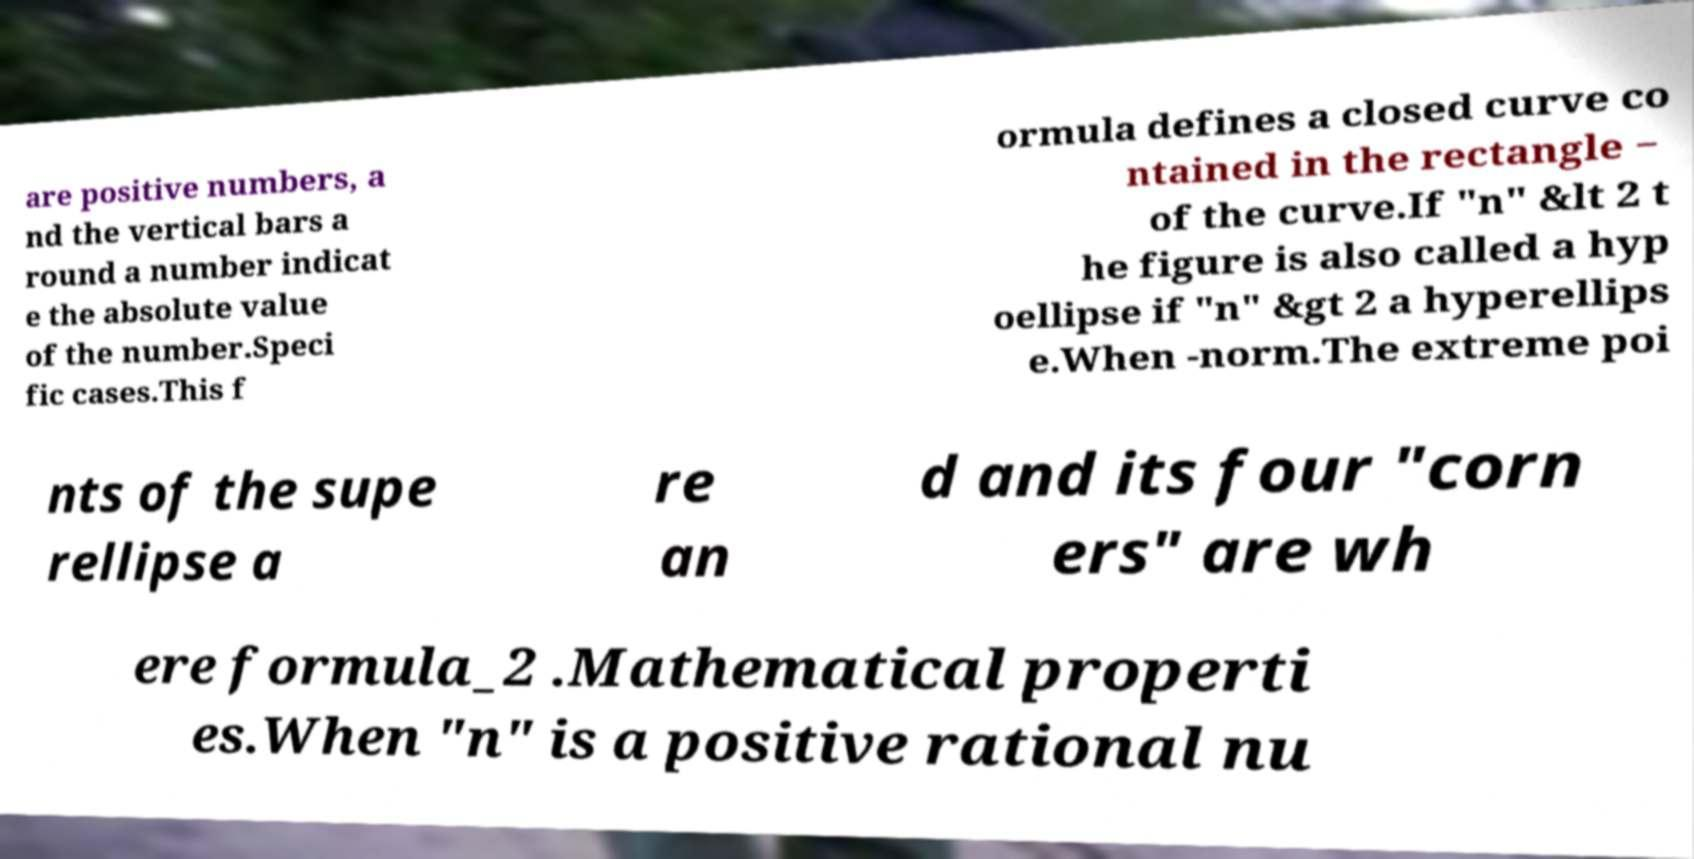Please read and relay the text visible in this image. What does it say? are positive numbers, a nd the vertical bars a round a number indicat e the absolute value of the number.Speci fic cases.This f ormula defines a closed curve co ntained in the rectangle − of the curve.If "n" &lt 2 t he figure is also called a hyp oellipse if "n" &gt 2 a hyperellips e.When -norm.The extreme poi nts of the supe rellipse a re an d and its four "corn ers" are wh ere formula_2 .Mathematical properti es.When "n" is a positive rational nu 